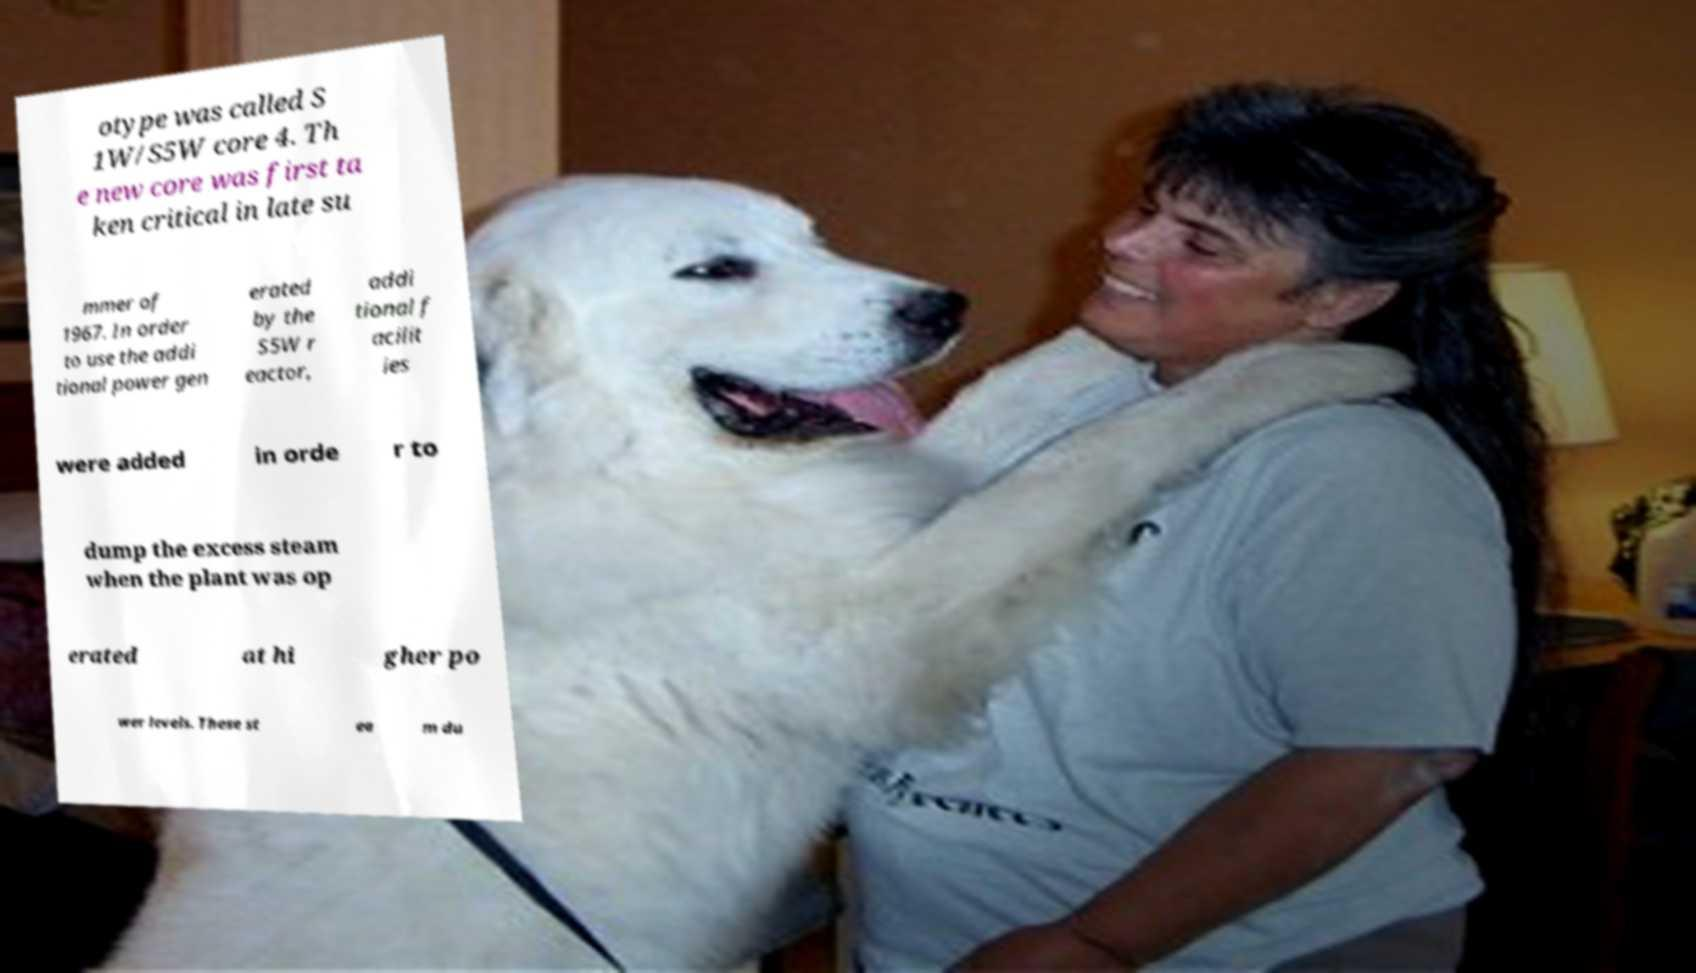Can you read and provide the text displayed in the image?This photo seems to have some interesting text. Can you extract and type it out for me? otype was called S 1W/S5W core 4. Th e new core was first ta ken critical in late su mmer of 1967. In order to use the addi tional power gen erated by the S5W r eactor, addi tional f acilit ies were added in orde r to dump the excess steam when the plant was op erated at hi gher po wer levels. These st ea m du 